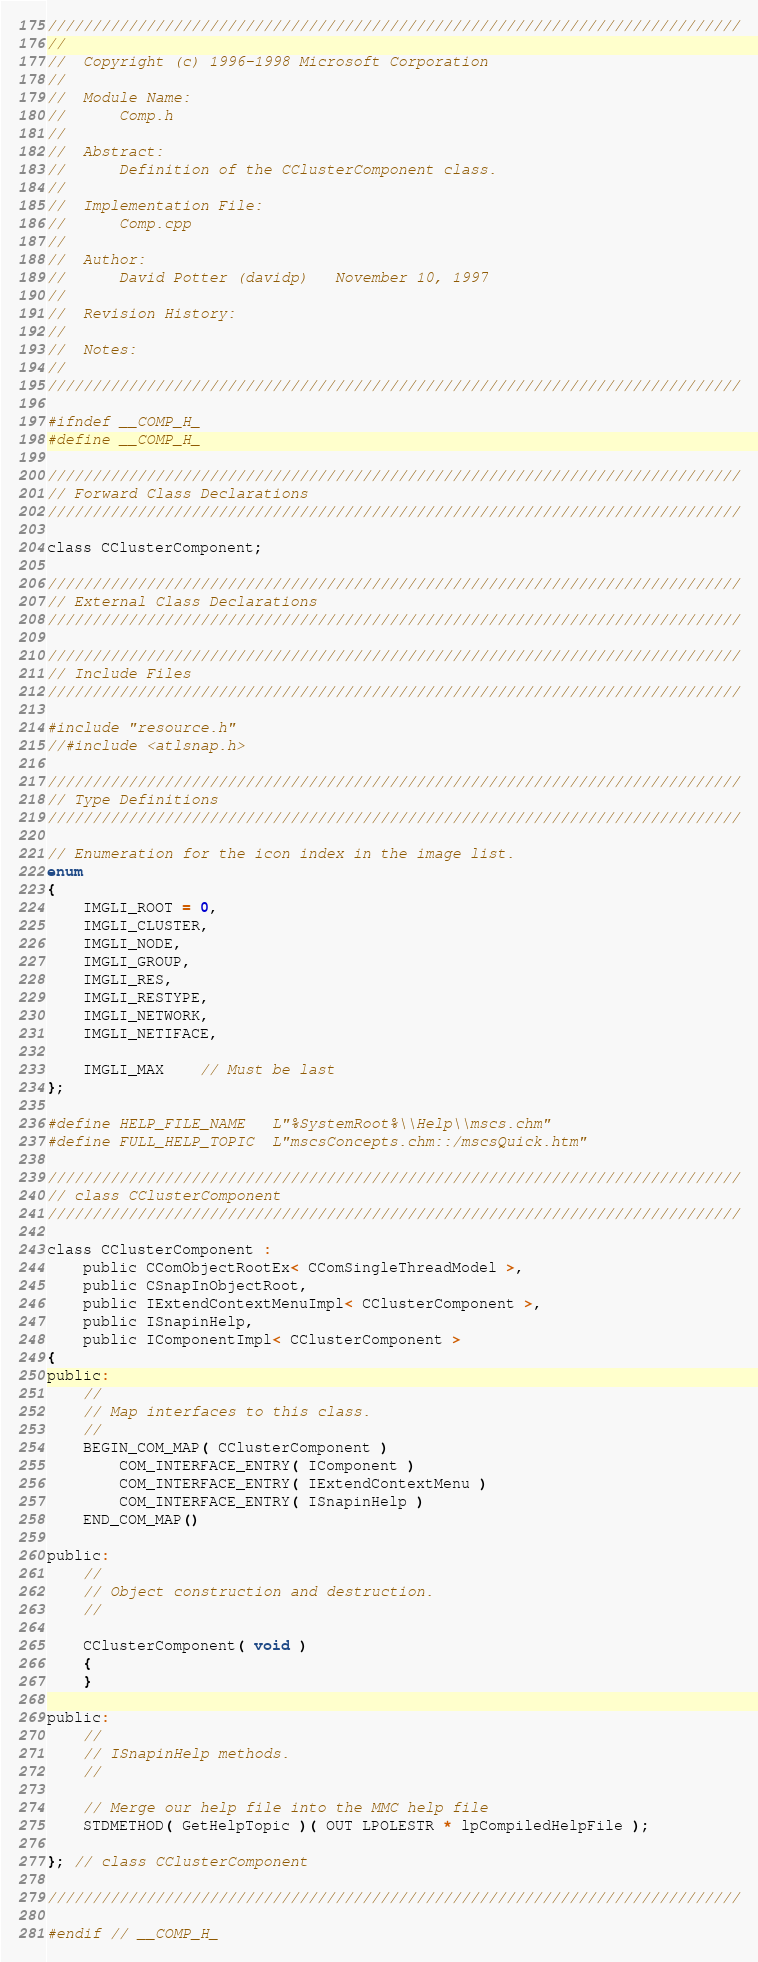<code> <loc_0><loc_0><loc_500><loc_500><_C_>/////////////////////////////////////////////////////////////////////////////
//
//	Copyright (c) 1996-1998 Microsoft Corporation
//
//	Module Name:
//		Comp.h
//
//	Abstract:
//		Definition of the CClusterComponent class.
//
//	Implementation File:
//		Comp.cpp
//
//	Author:
//		David Potter (davidp)	November 10, 1997
//
//	Revision History:
//
//	Notes:
//
/////////////////////////////////////////////////////////////////////////////

#ifndef __COMP_H_
#define __COMP_H_

/////////////////////////////////////////////////////////////////////////////
// Forward Class Declarations
/////////////////////////////////////////////////////////////////////////////

class CClusterComponent;

/////////////////////////////////////////////////////////////////////////////
// External Class Declarations
/////////////////////////////////////////////////////////////////////////////

/////////////////////////////////////////////////////////////////////////////
// Include Files
/////////////////////////////////////////////////////////////////////////////

#include "resource.h"
//#include <atlsnap.h>

/////////////////////////////////////////////////////////////////////////////
// Type Definitions
/////////////////////////////////////////////////////////////////////////////

// Enumeration for the icon index in the image list.
enum
{
	IMGLI_ROOT = 0,
	IMGLI_CLUSTER,
	IMGLI_NODE,
	IMGLI_GROUP,
	IMGLI_RES,
	IMGLI_RESTYPE,
	IMGLI_NETWORK,
	IMGLI_NETIFACE,

	IMGLI_MAX	// Must be last
};

#define HELP_FILE_NAME	L"%SystemRoot%\\Help\\mscs.chm"
#define FULL_HELP_TOPIC	L"mscsConcepts.chm::/mscsQuick.htm"

/////////////////////////////////////////////////////////////////////////////
// class CClusterComponent
/////////////////////////////////////////////////////////////////////////////

class CClusterComponent :
	public CComObjectRootEx< CComSingleThreadModel >,
	public CSnapInObjectRoot,
	public IExtendContextMenuImpl< CClusterComponent >,
	public ISnapinHelp,
	public IComponentImpl< CClusterComponent >
{
public:
	//
	// Map interfaces to this class.
	//
	BEGIN_COM_MAP( CClusterComponent )
		COM_INTERFACE_ENTRY( IComponent )
		COM_INTERFACE_ENTRY( IExtendContextMenu )
		COM_INTERFACE_ENTRY( ISnapinHelp )
	END_COM_MAP()

public:
	//
	// Object construction and destruction.
	//

	CClusterComponent( void )
	{
	}

public:
	//
	// ISnapinHelp methods.
	//

	// Merge our help file into the MMC help file
	STDMETHOD( GetHelpTopic )( OUT LPOLESTR * lpCompiledHelpFile );

}; // class CClusterComponent

/////////////////////////////////////////////////////////////////////////////

#endif // __COMP_H_
</code> 